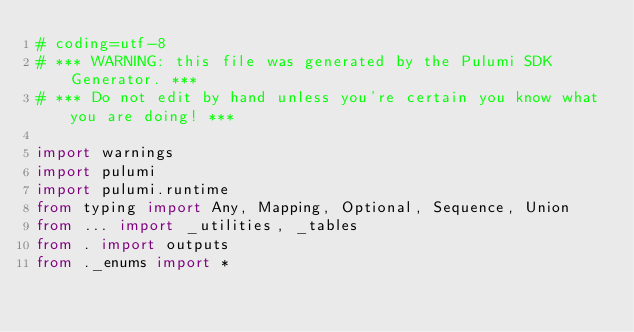Convert code to text. <code><loc_0><loc_0><loc_500><loc_500><_Python_># coding=utf-8
# *** WARNING: this file was generated by the Pulumi SDK Generator. ***
# *** Do not edit by hand unless you're certain you know what you are doing! ***

import warnings
import pulumi
import pulumi.runtime
from typing import Any, Mapping, Optional, Sequence, Union
from ... import _utilities, _tables
from . import outputs
from ._enums import *</code> 